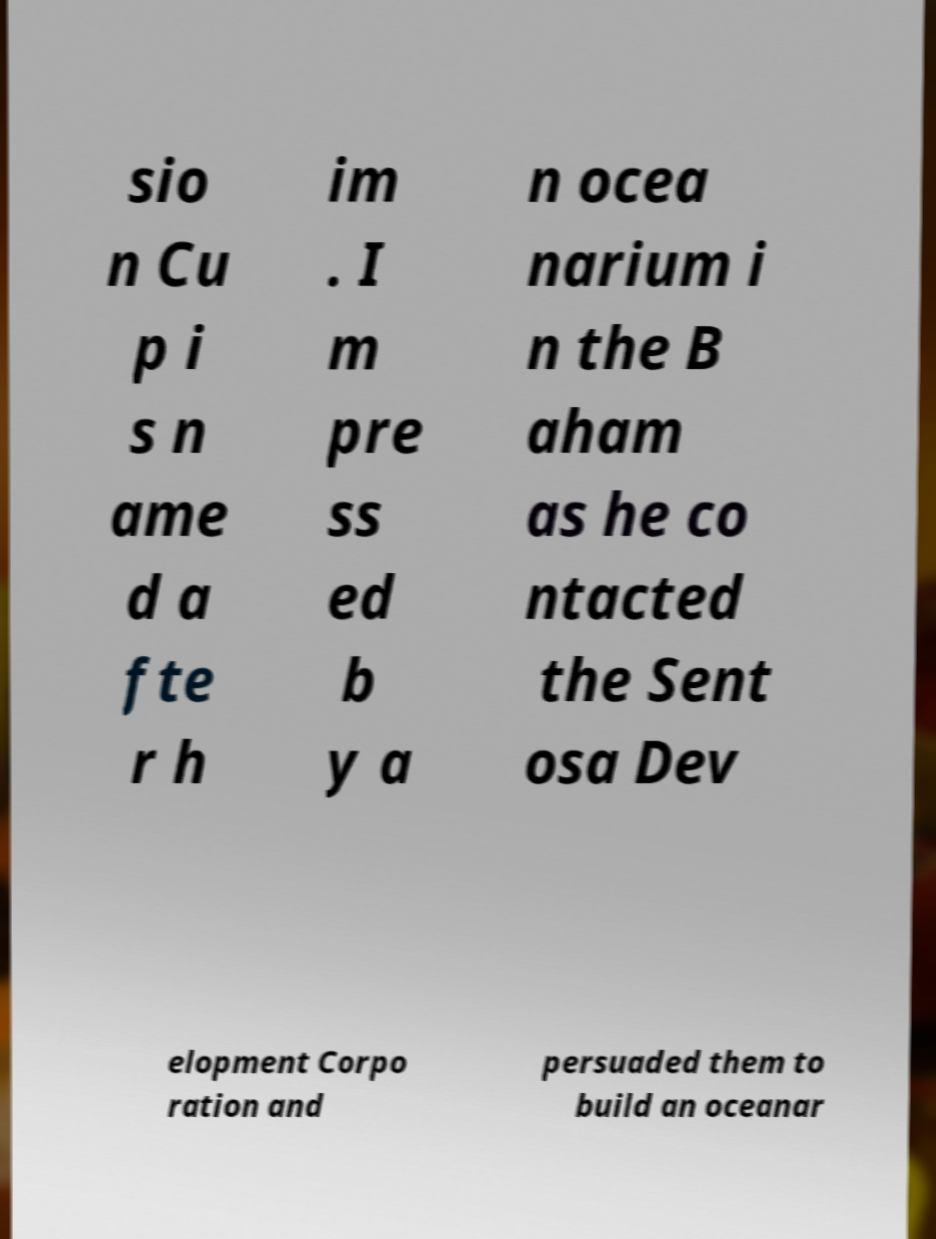What messages or text are displayed in this image? I need them in a readable, typed format. sio n Cu p i s n ame d a fte r h im . I m pre ss ed b y a n ocea narium i n the B aham as he co ntacted the Sent osa Dev elopment Corpo ration and persuaded them to build an oceanar 